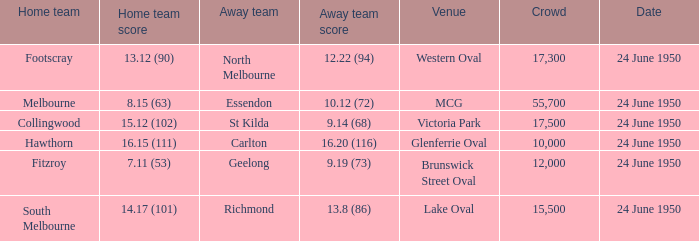Who was the home team for the game where North Melbourne was the away team and the crowd was over 12,000? Footscray. Can you give me this table as a dict? {'header': ['Home team', 'Home team score', 'Away team', 'Away team score', 'Venue', 'Crowd', 'Date'], 'rows': [['Footscray', '13.12 (90)', 'North Melbourne', '12.22 (94)', 'Western Oval', '17,300', '24 June 1950'], ['Melbourne', '8.15 (63)', 'Essendon', '10.12 (72)', 'MCG', '55,700', '24 June 1950'], ['Collingwood', '15.12 (102)', 'St Kilda', '9.14 (68)', 'Victoria Park', '17,500', '24 June 1950'], ['Hawthorn', '16.15 (111)', 'Carlton', '16.20 (116)', 'Glenferrie Oval', '10,000', '24 June 1950'], ['Fitzroy', '7.11 (53)', 'Geelong', '9.19 (73)', 'Brunswick Street Oval', '12,000', '24 June 1950'], ['South Melbourne', '14.17 (101)', 'Richmond', '13.8 (86)', 'Lake Oval', '15,500', '24 June 1950']]} 